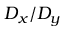Convert formula to latex. <formula><loc_0><loc_0><loc_500><loc_500>D _ { x } / D _ { y }</formula> 